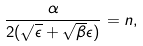Convert formula to latex. <formula><loc_0><loc_0><loc_500><loc_500>\frac { \alpha } { 2 ( \sqrt { \epsilon } + \sqrt { \beta } \epsilon ) } = n ,</formula> 